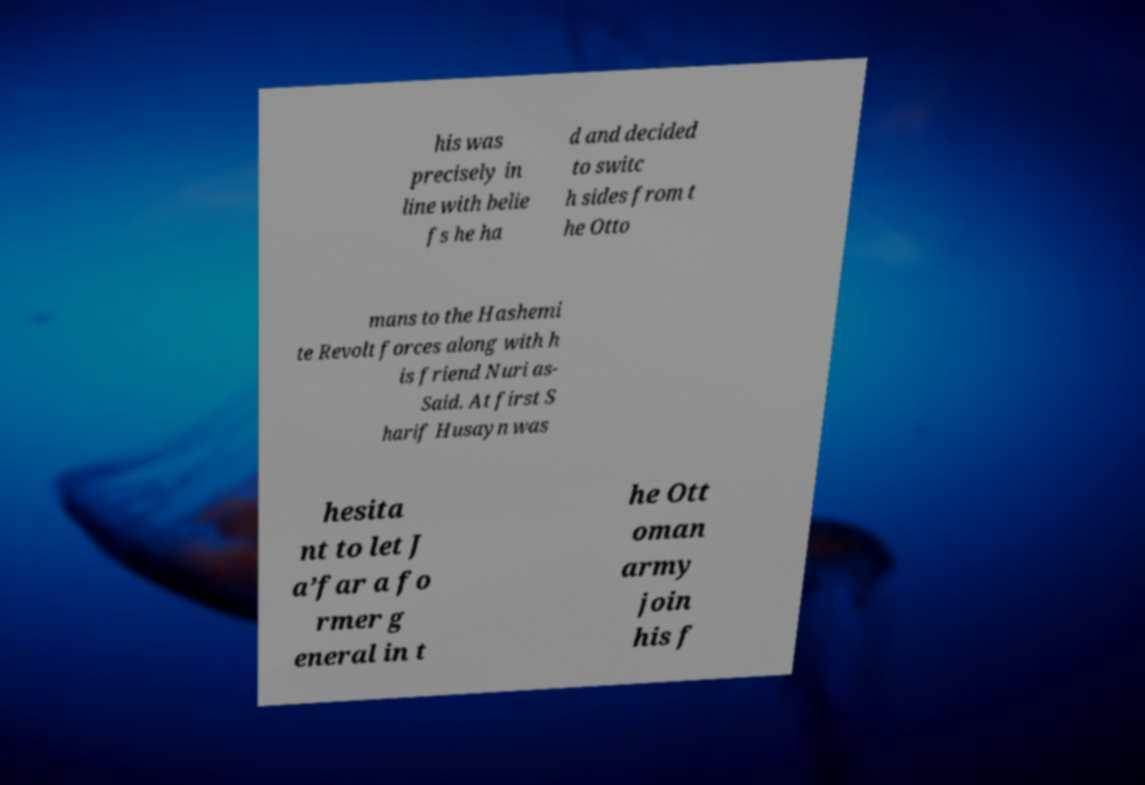Could you extract and type out the text from this image? his was precisely in line with belie fs he ha d and decided to switc h sides from t he Otto mans to the Hashemi te Revolt forces along with h is friend Nuri as- Said. At first S harif Husayn was hesita nt to let J a’far a fo rmer g eneral in t he Ott oman army join his f 